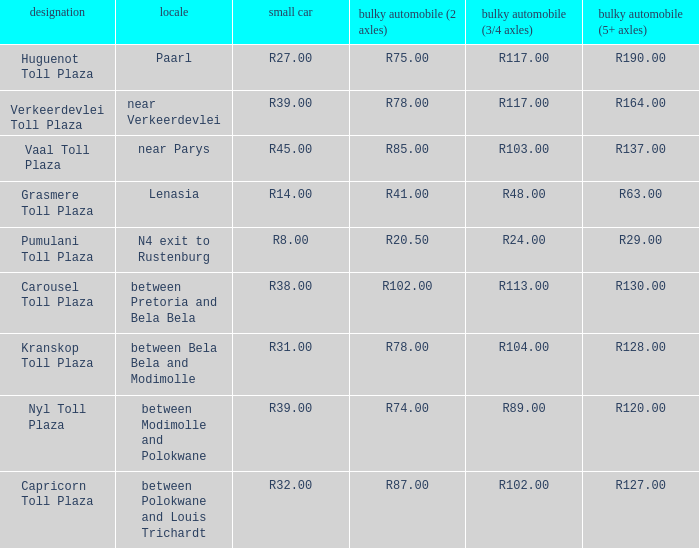What is the location of the Carousel toll plaza? Between pretoria and bela bela. 